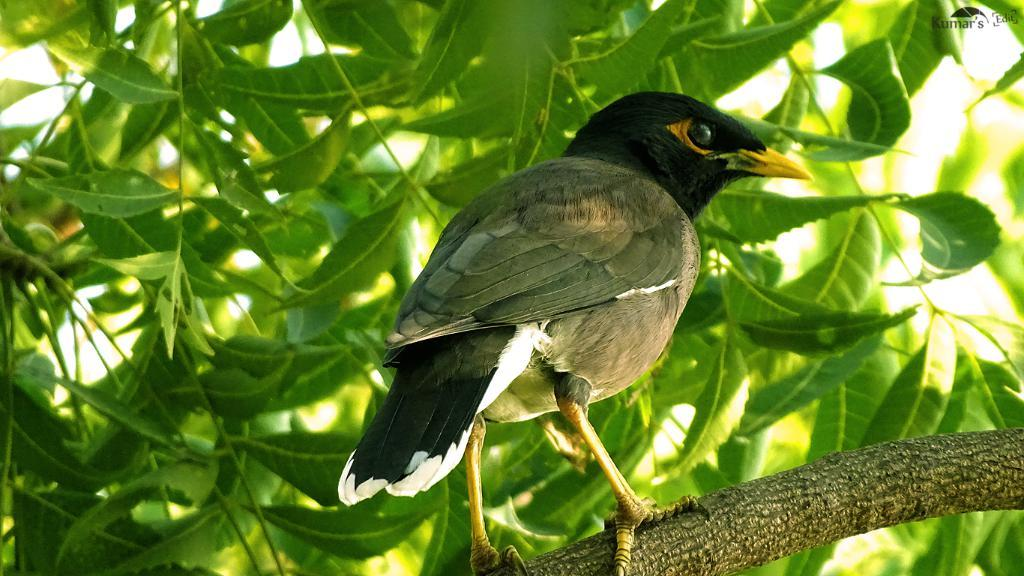What type of animal can be seen in the image? There is a bird in the image. Where is the bird located? The bird is on a tree branch. What can be seen in the background of the image? There are leaves visible in the background of the image. What is present in the top right corner of the image? There is some text in the top right corner of the image. What type of finger can be seen holding the bird in the image? There is no finger holding the bird in the image; the bird is on a tree branch. What type of brick is visible in the image? There is no brick present in the image. 